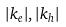Convert formula to latex. <formula><loc_0><loc_0><loc_500><loc_500>| k _ { e } | , | k _ { h } |</formula> 